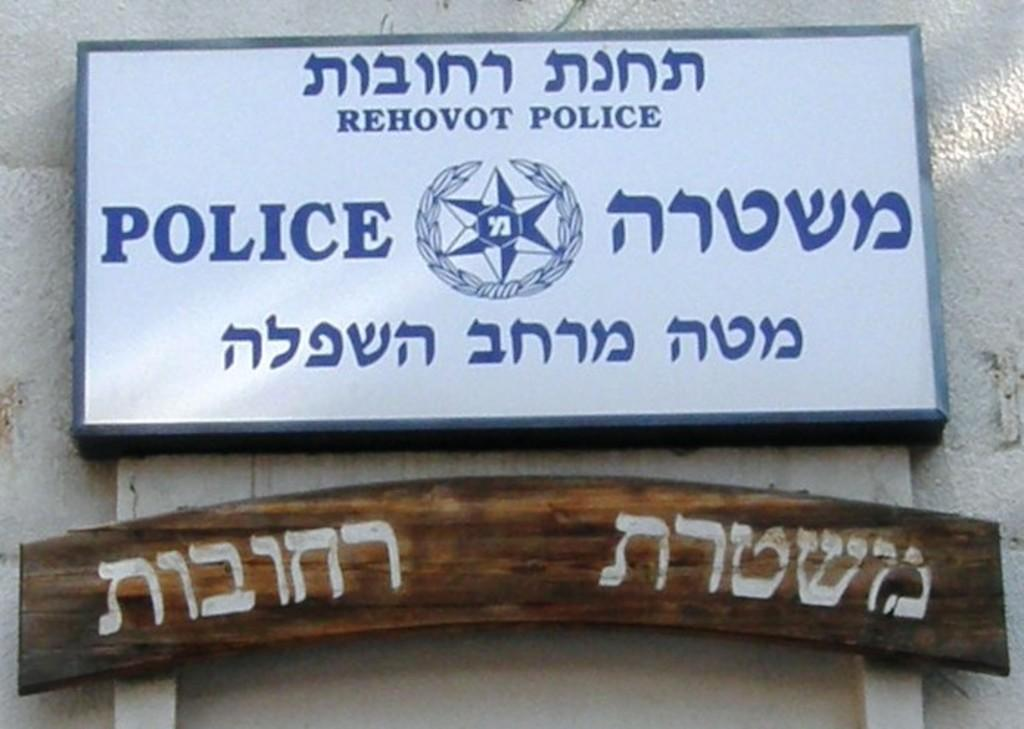<image>
Summarize the visual content of the image. A blue and white sign indicates a police facility. 